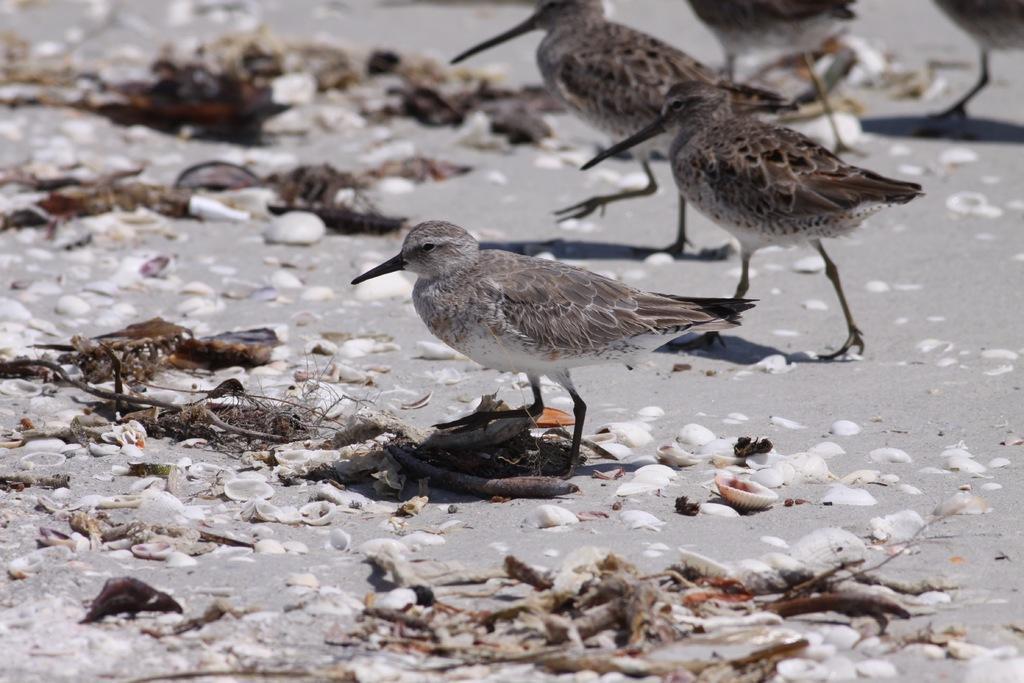How would you summarize this image in a sentence or two? In this picture we can see few birds and shells. 